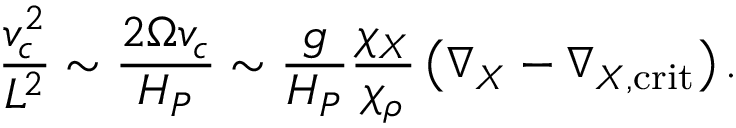Convert formula to latex. <formula><loc_0><loc_0><loc_500><loc_500>{ \frac { v _ { c } ^ { 2 } } { L ^ { 2 } } } \sim { \frac { 2 \Omega v _ { c } } { H _ { P } } } \sim { \frac { g } { H _ { P } } } { \frac { \chi _ { X } } { \chi _ { \rho } } } \left ( \nabla _ { X } - \nabla _ { X , c r i t } \right ) .</formula> 